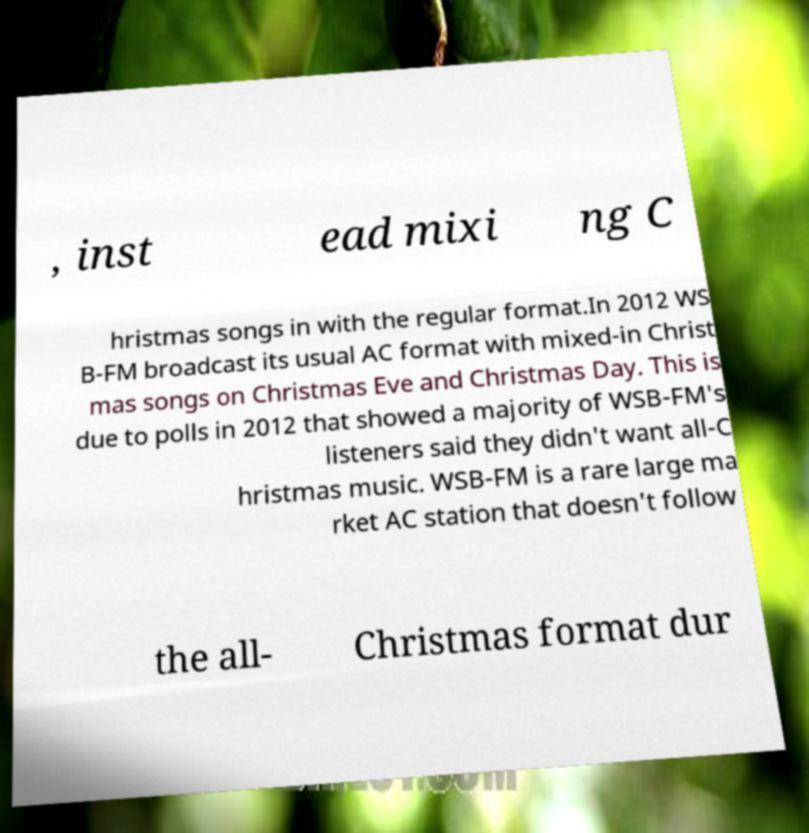Can you accurately transcribe the text from the provided image for me? , inst ead mixi ng C hristmas songs in with the regular format.In 2012 WS B-FM broadcast its usual AC format with mixed-in Christ mas songs on Christmas Eve and Christmas Day. This is due to polls in 2012 that showed a majority of WSB-FM's listeners said they didn't want all-C hristmas music. WSB-FM is a rare large ma rket AC station that doesn't follow the all- Christmas format dur 